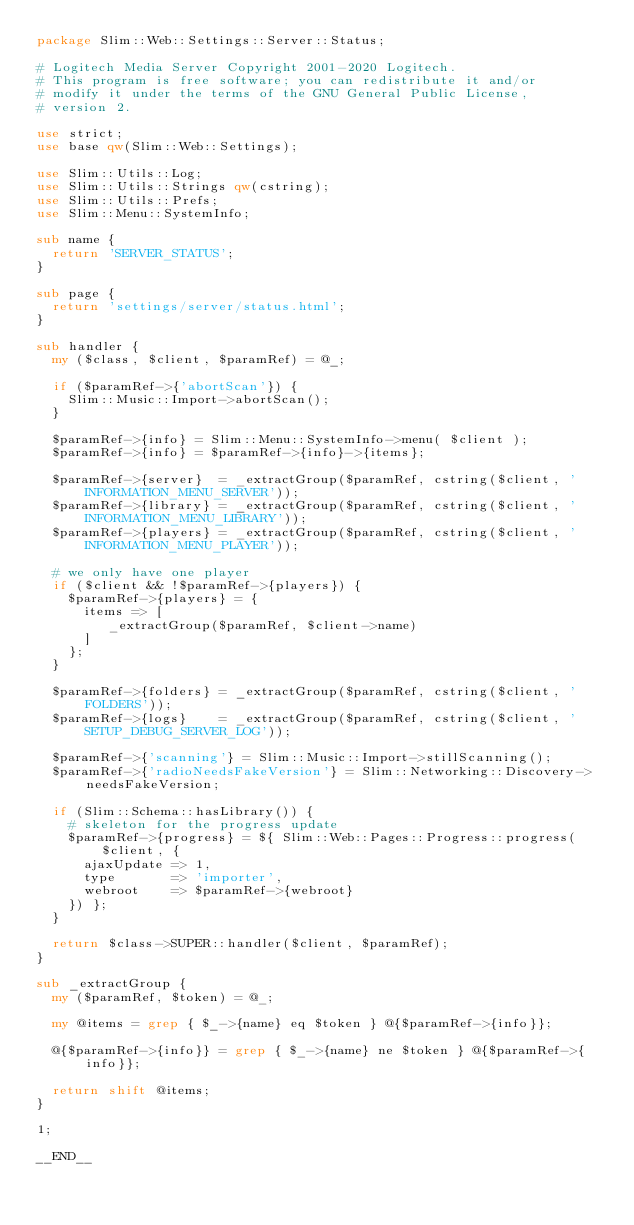<code> <loc_0><loc_0><loc_500><loc_500><_Perl_>package Slim::Web::Settings::Server::Status;

# Logitech Media Server Copyright 2001-2020 Logitech.
# This program is free software; you can redistribute it and/or
# modify it under the terms of the GNU General Public License,
# version 2.

use strict;
use base qw(Slim::Web::Settings);

use Slim::Utils::Log;
use Slim::Utils::Strings qw(cstring);
use Slim::Utils::Prefs;
use Slim::Menu::SystemInfo;

sub name {
	return 'SERVER_STATUS';
}

sub page {
	return 'settings/server/status.html';
}

sub handler {
	my ($class, $client, $paramRef) = @_;

	if ($paramRef->{'abortScan'}) {
		Slim::Music::Import->abortScan();
	}

	$paramRef->{info} = Slim::Menu::SystemInfo->menu( $client );
	$paramRef->{info} = $paramRef->{info}->{items};

	$paramRef->{server}  = _extractGroup($paramRef, cstring($client, 'INFORMATION_MENU_SERVER'));
	$paramRef->{library} = _extractGroup($paramRef, cstring($client, 'INFORMATION_MENU_LIBRARY'));
	$paramRef->{players} = _extractGroup($paramRef, cstring($client, 'INFORMATION_MENU_PLAYER'));

	# we only have one player
	if ($client && !$paramRef->{players}) {
		$paramRef->{players} = {
			items => [
				 _extractGroup($paramRef, $client->name)
			]
		};
	}

	$paramRef->{folders} = _extractGroup($paramRef, cstring($client, 'FOLDERS'));
	$paramRef->{logs}    = _extractGroup($paramRef, cstring($client, 'SETUP_DEBUG_SERVER_LOG'));

	$paramRef->{'scanning'} = Slim::Music::Import->stillScanning();
	$paramRef->{'radioNeedsFakeVersion'} = Slim::Networking::Discovery->needsFakeVersion;

	if (Slim::Schema::hasLibrary()) {
		# skeleton for the progress update
		$paramRef->{progress} = ${ Slim::Web::Pages::Progress::progress($client, {
			ajaxUpdate => 1,
			type       => 'importer',
			webroot    => $paramRef->{webroot}
		}) };
	}

	return $class->SUPER::handler($client, $paramRef);
}

sub _extractGroup {
	my ($paramRef, $token) = @_;

	my @items = grep { $_->{name} eq $token } @{$paramRef->{info}};

	@{$paramRef->{info}} = grep { $_->{name} ne $token } @{$paramRef->{info}};

	return shift @items;
}

1;

__END__
</code> 